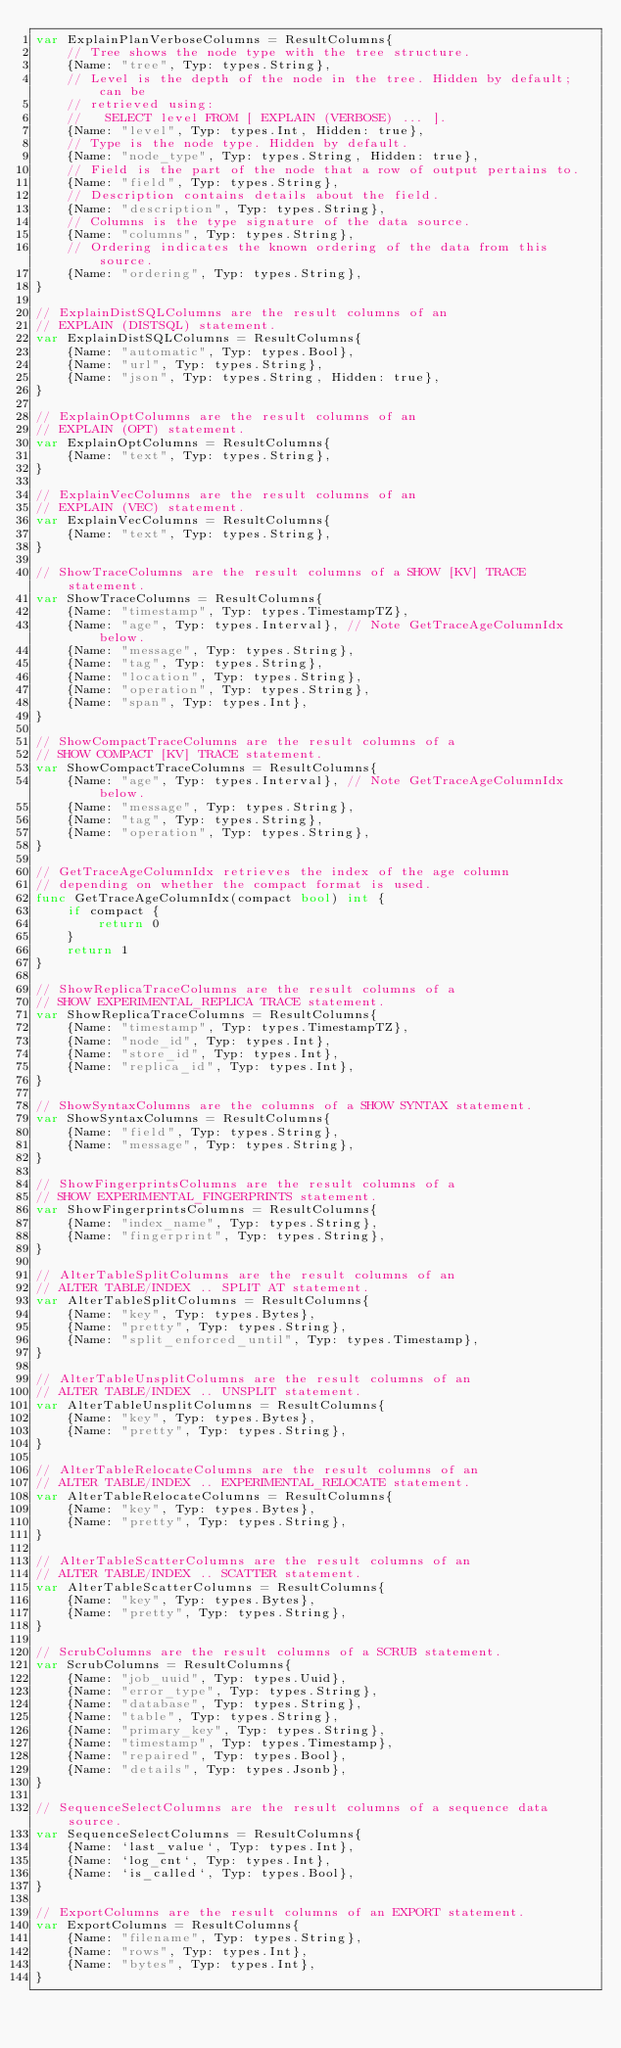Convert code to text. <code><loc_0><loc_0><loc_500><loc_500><_Go_>var ExplainPlanVerboseColumns = ResultColumns{
	// Tree shows the node type with the tree structure.
	{Name: "tree", Typ: types.String},
	// Level is the depth of the node in the tree. Hidden by default; can be
	// retrieved using:
	//   SELECT level FROM [ EXPLAIN (VERBOSE) ... ].
	{Name: "level", Typ: types.Int, Hidden: true},
	// Type is the node type. Hidden by default.
	{Name: "node_type", Typ: types.String, Hidden: true},
	// Field is the part of the node that a row of output pertains to.
	{Name: "field", Typ: types.String},
	// Description contains details about the field.
	{Name: "description", Typ: types.String},
	// Columns is the type signature of the data source.
	{Name: "columns", Typ: types.String},
	// Ordering indicates the known ordering of the data from this source.
	{Name: "ordering", Typ: types.String},
}

// ExplainDistSQLColumns are the result columns of an
// EXPLAIN (DISTSQL) statement.
var ExplainDistSQLColumns = ResultColumns{
	{Name: "automatic", Typ: types.Bool},
	{Name: "url", Typ: types.String},
	{Name: "json", Typ: types.String, Hidden: true},
}

// ExplainOptColumns are the result columns of an
// EXPLAIN (OPT) statement.
var ExplainOptColumns = ResultColumns{
	{Name: "text", Typ: types.String},
}

// ExplainVecColumns are the result columns of an
// EXPLAIN (VEC) statement.
var ExplainVecColumns = ResultColumns{
	{Name: "text", Typ: types.String},
}

// ShowTraceColumns are the result columns of a SHOW [KV] TRACE statement.
var ShowTraceColumns = ResultColumns{
	{Name: "timestamp", Typ: types.TimestampTZ},
	{Name: "age", Typ: types.Interval}, // Note GetTraceAgeColumnIdx below.
	{Name: "message", Typ: types.String},
	{Name: "tag", Typ: types.String},
	{Name: "location", Typ: types.String},
	{Name: "operation", Typ: types.String},
	{Name: "span", Typ: types.Int},
}

// ShowCompactTraceColumns are the result columns of a
// SHOW COMPACT [KV] TRACE statement.
var ShowCompactTraceColumns = ResultColumns{
	{Name: "age", Typ: types.Interval}, // Note GetTraceAgeColumnIdx below.
	{Name: "message", Typ: types.String},
	{Name: "tag", Typ: types.String},
	{Name: "operation", Typ: types.String},
}

// GetTraceAgeColumnIdx retrieves the index of the age column
// depending on whether the compact format is used.
func GetTraceAgeColumnIdx(compact bool) int {
	if compact {
		return 0
	}
	return 1
}

// ShowReplicaTraceColumns are the result columns of a
// SHOW EXPERIMENTAL_REPLICA TRACE statement.
var ShowReplicaTraceColumns = ResultColumns{
	{Name: "timestamp", Typ: types.TimestampTZ},
	{Name: "node_id", Typ: types.Int},
	{Name: "store_id", Typ: types.Int},
	{Name: "replica_id", Typ: types.Int},
}

// ShowSyntaxColumns are the columns of a SHOW SYNTAX statement.
var ShowSyntaxColumns = ResultColumns{
	{Name: "field", Typ: types.String},
	{Name: "message", Typ: types.String},
}

// ShowFingerprintsColumns are the result columns of a
// SHOW EXPERIMENTAL_FINGERPRINTS statement.
var ShowFingerprintsColumns = ResultColumns{
	{Name: "index_name", Typ: types.String},
	{Name: "fingerprint", Typ: types.String},
}

// AlterTableSplitColumns are the result columns of an
// ALTER TABLE/INDEX .. SPLIT AT statement.
var AlterTableSplitColumns = ResultColumns{
	{Name: "key", Typ: types.Bytes},
	{Name: "pretty", Typ: types.String},
	{Name: "split_enforced_until", Typ: types.Timestamp},
}

// AlterTableUnsplitColumns are the result columns of an
// ALTER TABLE/INDEX .. UNSPLIT statement.
var AlterTableUnsplitColumns = ResultColumns{
	{Name: "key", Typ: types.Bytes},
	{Name: "pretty", Typ: types.String},
}

// AlterTableRelocateColumns are the result columns of an
// ALTER TABLE/INDEX .. EXPERIMENTAL_RELOCATE statement.
var AlterTableRelocateColumns = ResultColumns{
	{Name: "key", Typ: types.Bytes},
	{Name: "pretty", Typ: types.String},
}

// AlterTableScatterColumns are the result columns of an
// ALTER TABLE/INDEX .. SCATTER statement.
var AlterTableScatterColumns = ResultColumns{
	{Name: "key", Typ: types.Bytes},
	{Name: "pretty", Typ: types.String},
}

// ScrubColumns are the result columns of a SCRUB statement.
var ScrubColumns = ResultColumns{
	{Name: "job_uuid", Typ: types.Uuid},
	{Name: "error_type", Typ: types.String},
	{Name: "database", Typ: types.String},
	{Name: "table", Typ: types.String},
	{Name: "primary_key", Typ: types.String},
	{Name: "timestamp", Typ: types.Timestamp},
	{Name: "repaired", Typ: types.Bool},
	{Name: "details", Typ: types.Jsonb},
}

// SequenceSelectColumns are the result columns of a sequence data source.
var SequenceSelectColumns = ResultColumns{
	{Name: `last_value`, Typ: types.Int},
	{Name: `log_cnt`, Typ: types.Int},
	{Name: `is_called`, Typ: types.Bool},
}

// ExportColumns are the result columns of an EXPORT statement.
var ExportColumns = ResultColumns{
	{Name: "filename", Typ: types.String},
	{Name: "rows", Typ: types.Int},
	{Name: "bytes", Typ: types.Int},
}
</code> 